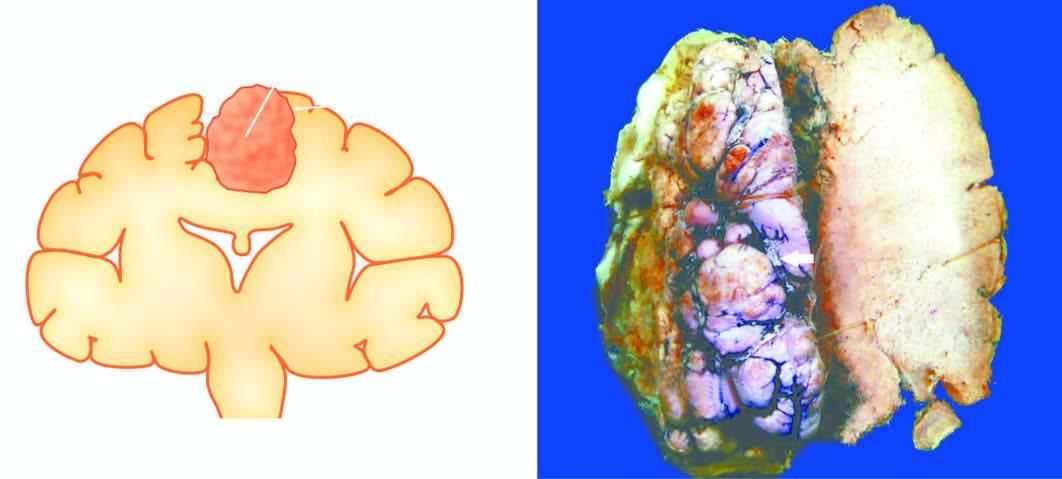what is firm and fibrous?
Answer the question using a single word or phrase. Cut surface of the mass 